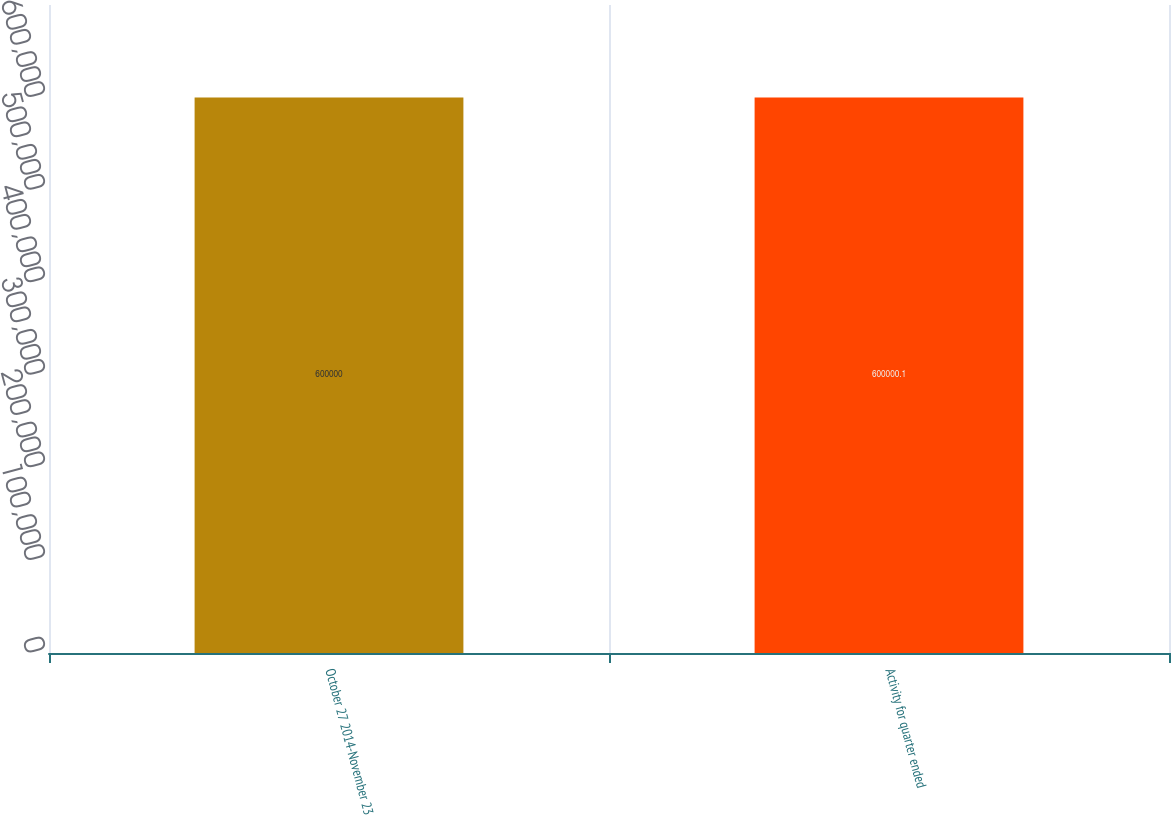Convert chart. <chart><loc_0><loc_0><loc_500><loc_500><bar_chart><fcel>October 27 2014-November 23<fcel>Activity for quarter ended<nl><fcel>600000<fcel>600000<nl></chart> 